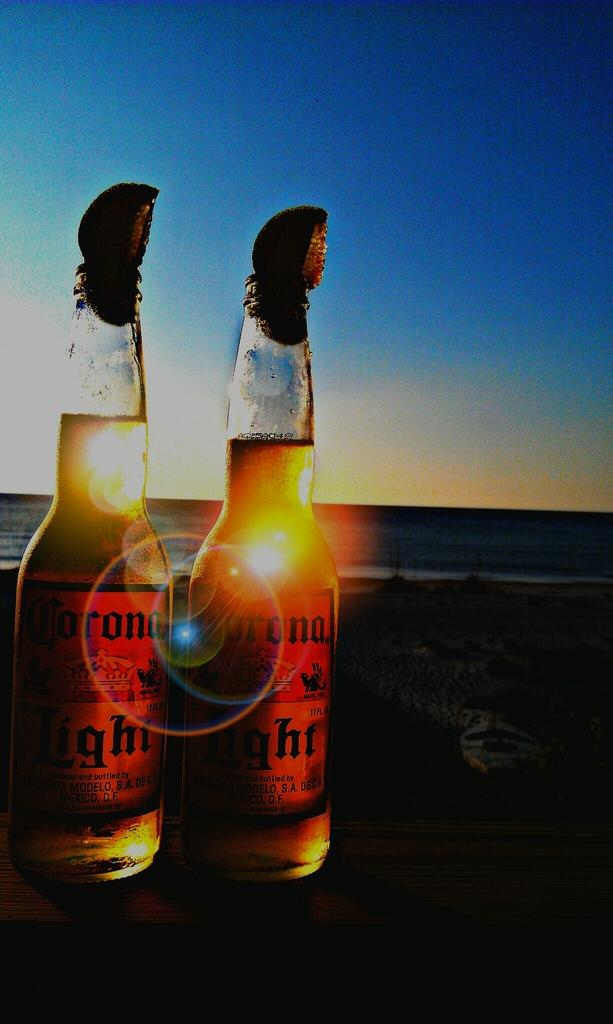<image>
Present a compact description of the photo's key features. Two bottles of Corona are in front of a sunset. 